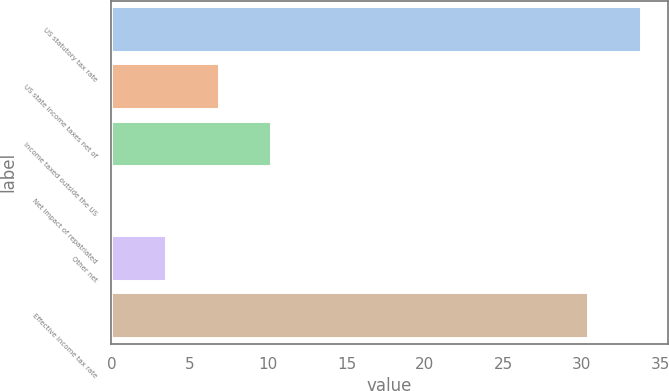Convert chart. <chart><loc_0><loc_0><loc_500><loc_500><bar_chart><fcel>US statutory tax rate<fcel>US state income taxes net of<fcel>Income taxed outside the US<fcel>Net impact of repatriated<fcel>Other net<fcel>Effective income tax rate<nl><fcel>33.8<fcel>6.84<fcel>10.21<fcel>0.1<fcel>3.47<fcel>30.4<nl></chart> 